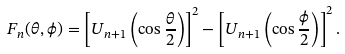Convert formula to latex. <formula><loc_0><loc_0><loc_500><loc_500>F _ { n } ( \theta , \phi ) = \left [ U _ { n + 1 } \left ( \cos \frac { \theta } { 2 } \right ) \right ] ^ { 2 } - \left [ U _ { n + 1 } \left ( \cos \frac { \phi } { 2 } \right ) \right ] ^ { 2 } .</formula> 